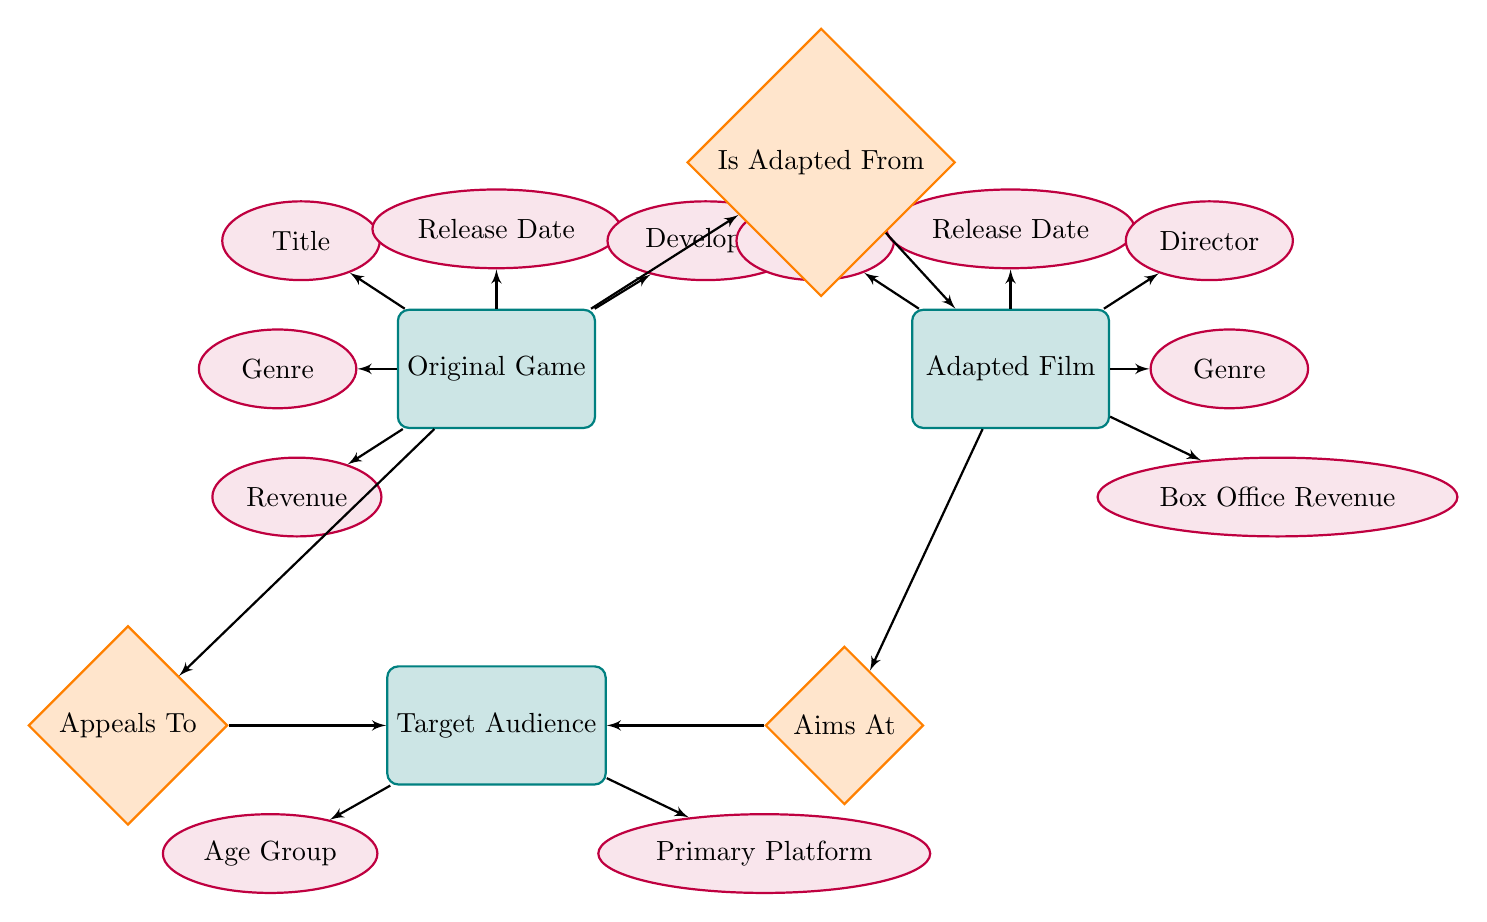What is the total number of entities in the diagram? The diagram includes three entities labeled Original Game, Adapted Film, and Target Audience. Each entity is distinctly represented, so the total count is three.
Answer: 3 What is one attribute of the Adapted Film entity? The Adapted Film entity contains several attributes, one of which is Title, as indicated in the diagram where Title is connected directly to the Adapted Film entity.
Answer: Title Which relationship connects Original Game and Adapted Film? The relationship between Original Game and Adapted Film is labeled as "Is Adapted From," shown as a diamond connecting these two entities, indicating the adaptation process.
Answer: Is Adapted From How many attributes does the Original Game entity have? The Original Game entity has five distinct attributes, which include Title, Release Date, Developer, Genre, and Revenue, all connected to the Original Game entity in the diagram.
Answer: 5 What does the Target Audience entity appeal to? The Target Audience entity is connected to the Original Game entity through the relationship labeled "Appeals To," indicating that it is influenced by the Original Game.
Answer: Original Game Which entity's attributes include Box Office Revenue? The Adapted Film entity includes the attribute Box Office Revenue, which is connected directly from the Adapted Film entity in the diagram, indicating it is an essential characteristic of the films.
Answer: Adapted Film What is the relationship between Adapted Film and Target Audience? The relationship that describes how Adapted Film relates to Target Audience is labeled "Aims At," which indicates the intended audience for the film adaptations.
Answer: Aims At What is the primary connection type used between entities in this diagram? The primary connection type in this diagram consists of relationships, which are exclusively represented with diamonds leading between the entities, emphasizing their interaction.
Answer: Relationships 